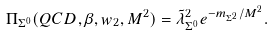<formula> <loc_0><loc_0><loc_500><loc_500>\Pi _ { \Sigma ^ { 0 } } ( Q C D , \beta , w _ { 2 } , M ^ { 2 } ) = \tilde { \lambda } _ { \Sigma ^ { 0 } } ^ { 2 } e ^ { - m _ { \Sigma ^ { 2 } } / M ^ { 2 } } .</formula> 